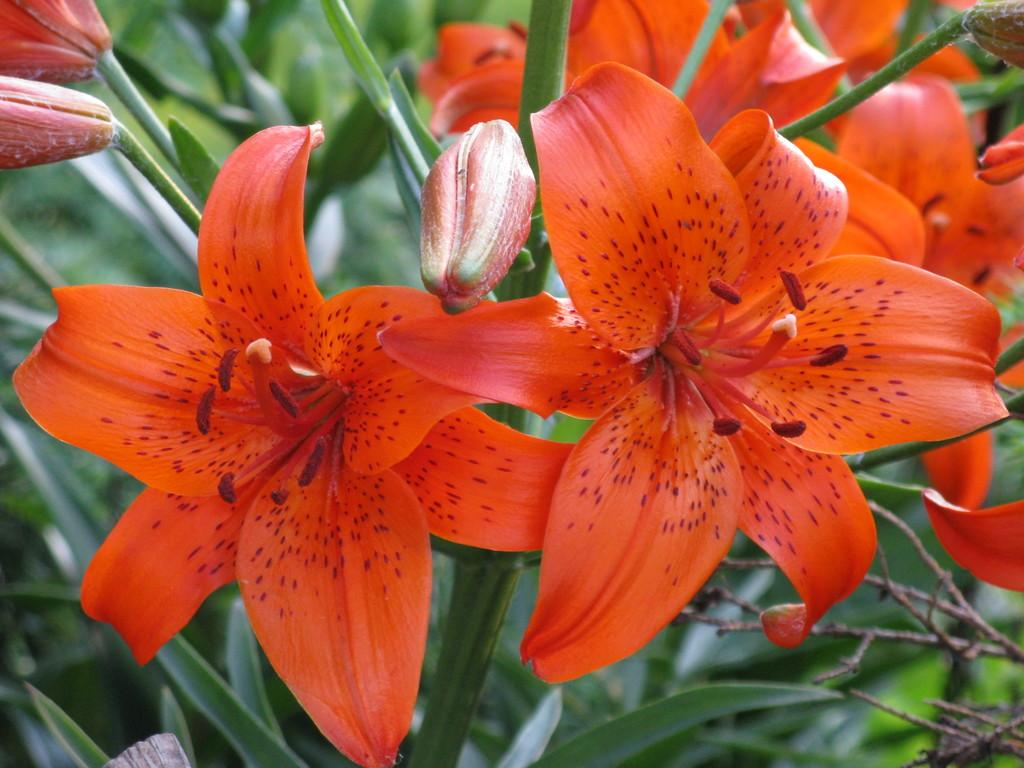What type of plants are in the image? There are flowers in the image. What color are the flowers? The flowers are red in color. What can be seen in the background of the image? There are green leaves in the background of the image. What time of day is it in the image? The time of day is not mentioned or visible in the image, so it cannot be determined. 